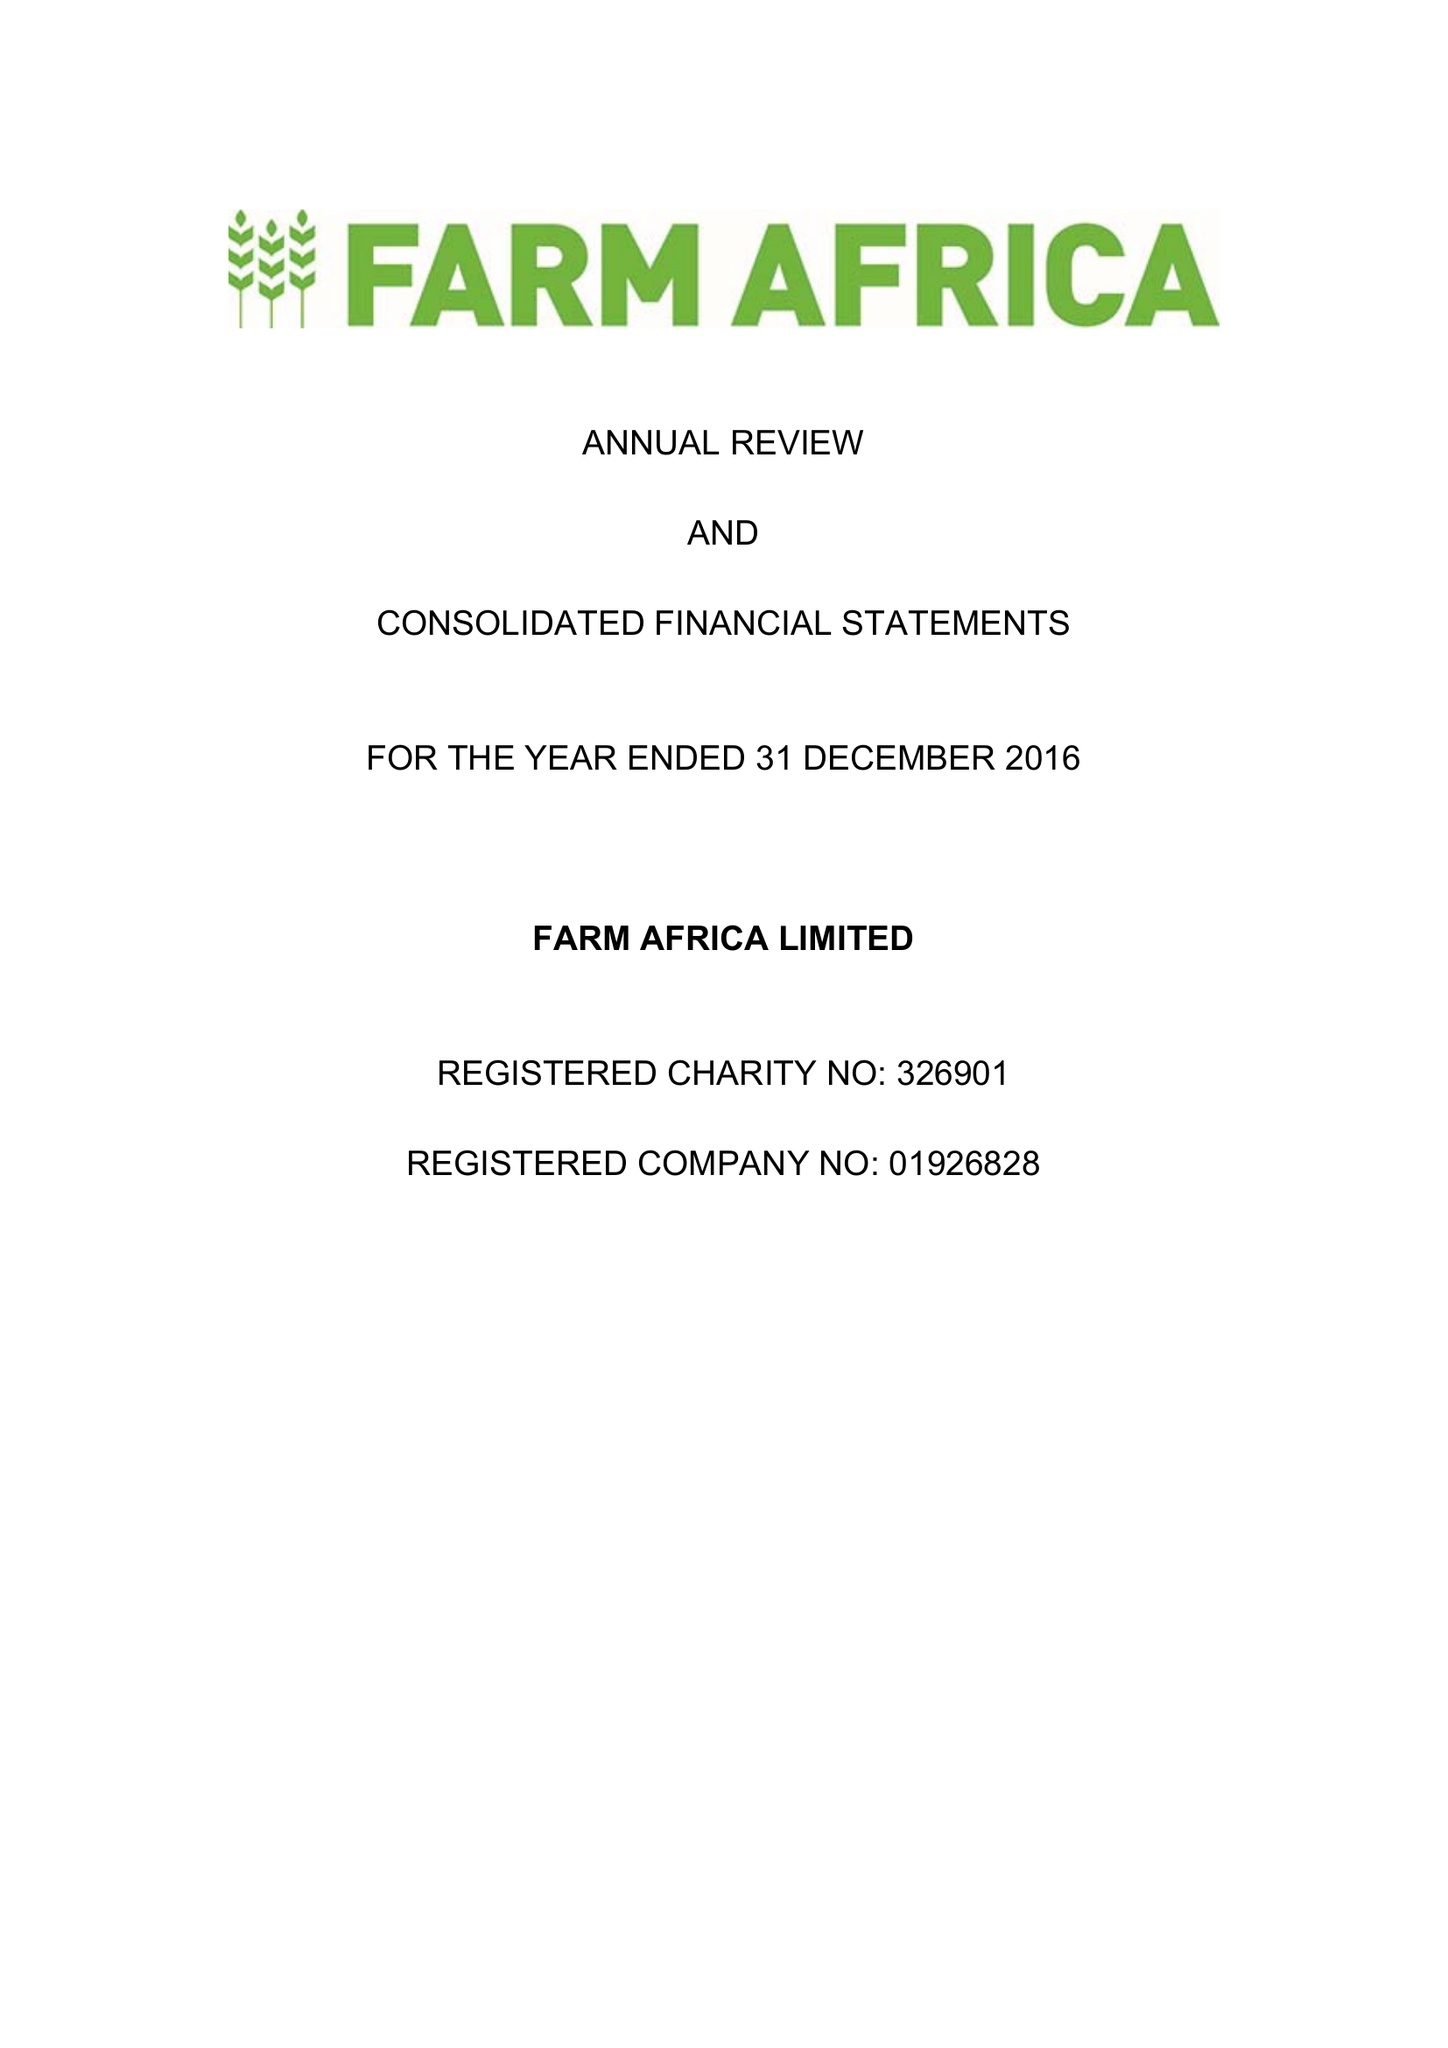What is the value for the income_annually_in_british_pounds?
Answer the question using a single word or phrase. 17900000.00 